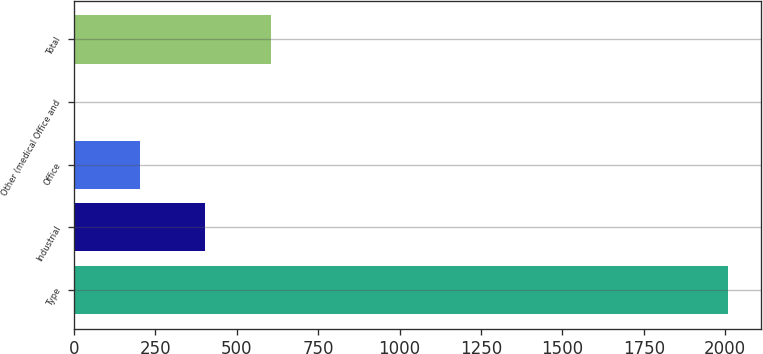Convert chart to OTSL. <chart><loc_0><loc_0><loc_500><loc_500><bar_chart><fcel>Type<fcel>Industrial<fcel>Office<fcel>Other (medical Office and<fcel>Total<nl><fcel>2008<fcel>403.04<fcel>202.42<fcel>1.8<fcel>603.66<nl></chart> 